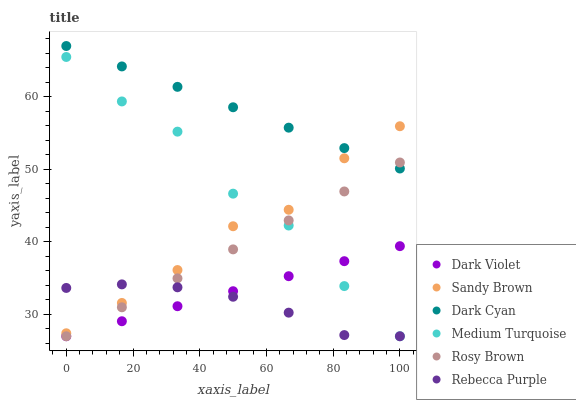Does Rebecca Purple have the minimum area under the curve?
Answer yes or no. Yes. Does Dark Cyan have the maximum area under the curve?
Answer yes or no. Yes. Does Dark Violet have the minimum area under the curve?
Answer yes or no. No. Does Dark Violet have the maximum area under the curve?
Answer yes or no. No. Is Rosy Brown the smoothest?
Answer yes or no. Yes. Is Medium Turquoise the roughest?
Answer yes or no. Yes. Is Dark Violet the smoothest?
Answer yes or no. No. Is Dark Violet the roughest?
Answer yes or no. No. Does Rosy Brown have the lowest value?
Answer yes or no. Yes. Does Dark Cyan have the lowest value?
Answer yes or no. No. Does Dark Cyan have the highest value?
Answer yes or no. Yes. Does Dark Violet have the highest value?
Answer yes or no. No. Is Dark Violet less than Sandy Brown?
Answer yes or no. Yes. Is Sandy Brown greater than Rosy Brown?
Answer yes or no. Yes. Does Medium Turquoise intersect Rosy Brown?
Answer yes or no. Yes. Is Medium Turquoise less than Rosy Brown?
Answer yes or no. No. Is Medium Turquoise greater than Rosy Brown?
Answer yes or no. No. Does Dark Violet intersect Sandy Brown?
Answer yes or no. No. 